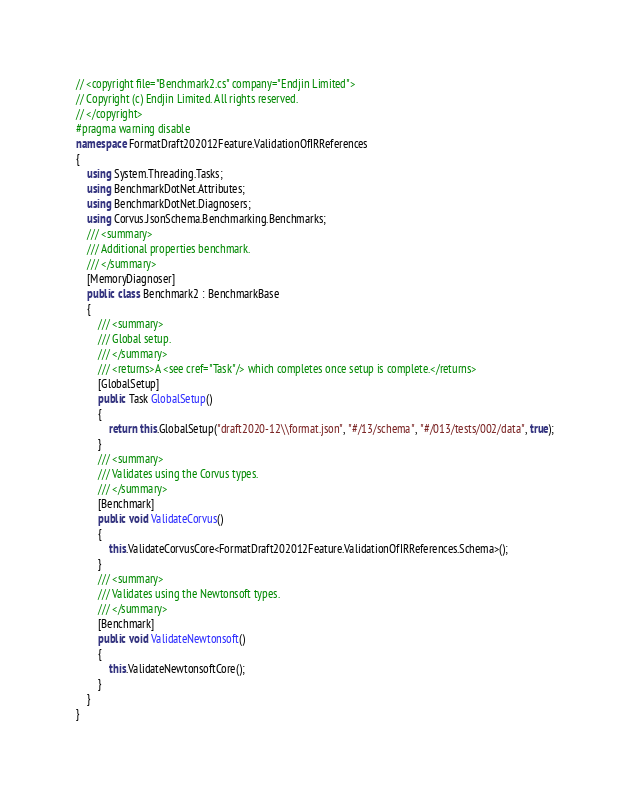<code> <loc_0><loc_0><loc_500><loc_500><_C#_>// <copyright file="Benchmark2.cs" company="Endjin Limited">
// Copyright (c) Endjin Limited. All rights reserved.
// </copyright>
#pragma warning disable
namespace FormatDraft202012Feature.ValidationOfIRReferences
{
    using System.Threading.Tasks;
    using BenchmarkDotNet.Attributes;
    using BenchmarkDotNet.Diagnosers;
    using Corvus.JsonSchema.Benchmarking.Benchmarks;
    /// <summary>
    /// Additional properties benchmark.
    /// </summary>
    [MemoryDiagnoser]
    public class Benchmark2 : BenchmarkBase
    {
        /// <summary>
        /// Global setup.
        /// </summary>
        /// <returns>A <see cref="Task"/> which completes once setup is complete.</returns>
        [GlobalSetup]
        public Task GlobalSetup()
        {
            return this.GlobalSetup("draft2020-12\\format.json", "#/13/schema", "#/013/tests/002/data", true);
        }
        /// <summary>
        /// Validates using the Corvus types.
        /// </summary>
        [Benchmark]
        public void ValidateCorvus()
        {
            this.ValidateCorvusCore<FormatDraft202012Feature.ValidationOfIRReferences.Schema>();
        }
        /// <summary>
        /// Validates using the Newtonsoft types.
        /// </summary>
        [Benchmark]
        public void ValidateNewtonsoft()
        {
            this.ValidateNewtonsoftCore();
        }
    }
}
</code> 